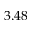Convert formula to latex. <formula><loc_0><loc_0><loc_500><loc_500>3 . 4 8</formula> 